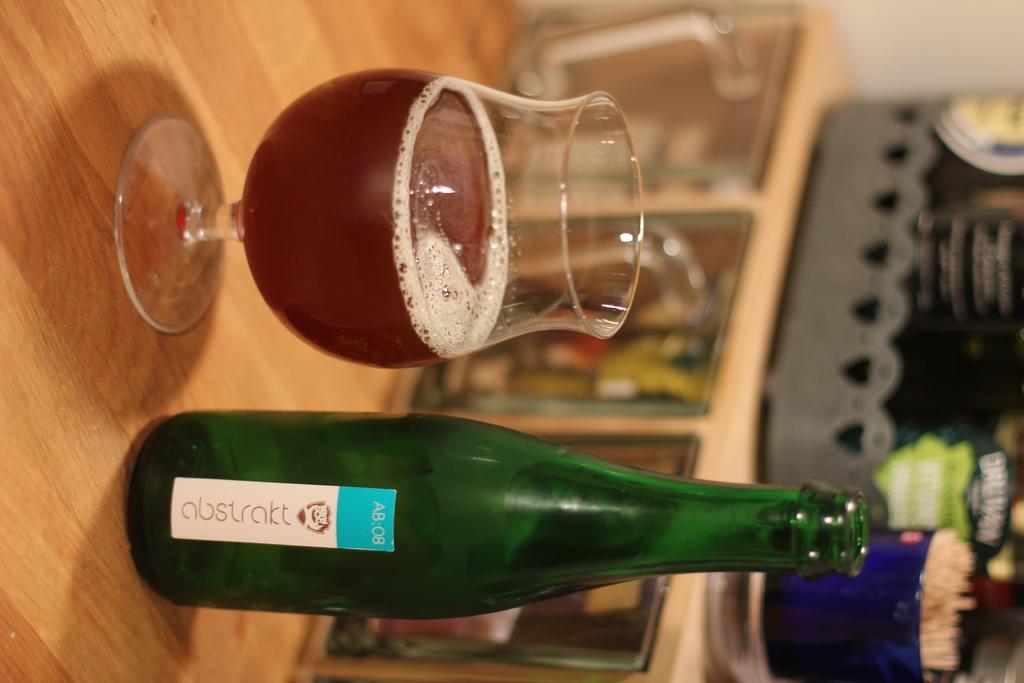What brand is this drink?
Offer a very short reply. Abstract. 